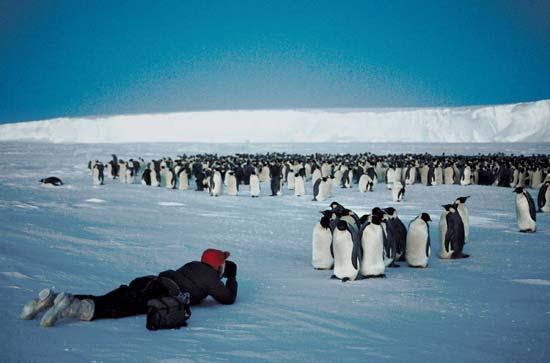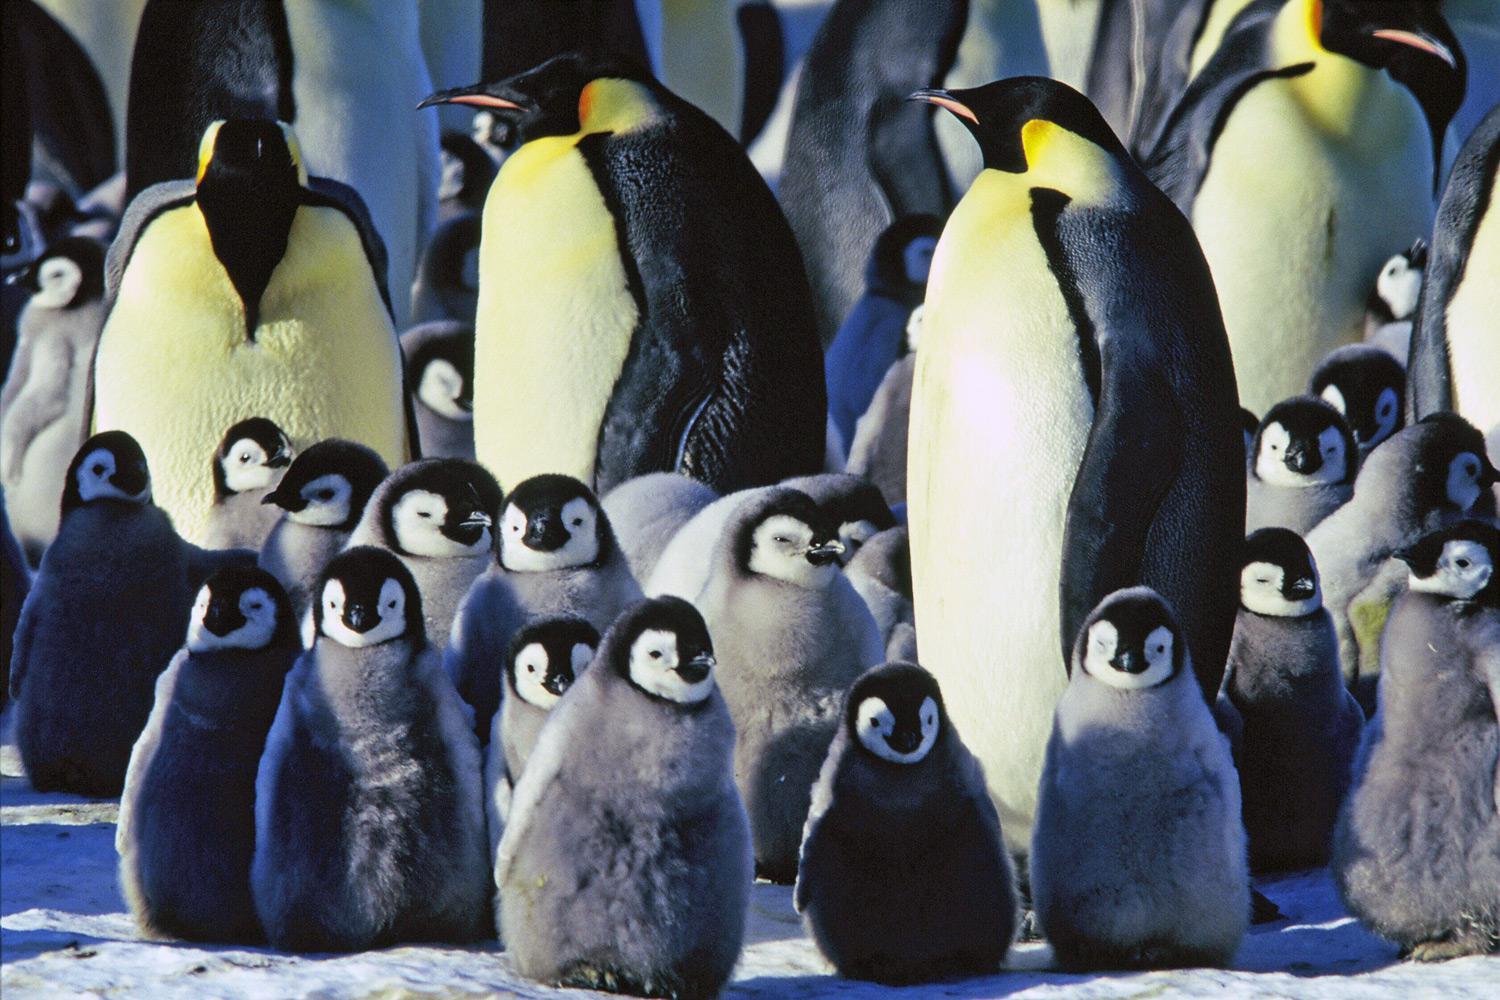The first image is the image on the left, the second image is the image on the right. Examine the images to the left and right. Is the description "One camera is attached to a tripod that's resting on the ground." accurate? Answer yes or no. No. The first image is the image on the left, the second image is the image on the right. Considering the images on both sides, is "An image includes at least one penguin and a person behind a scope on a tripod." valid? Answer yes or no. No. 